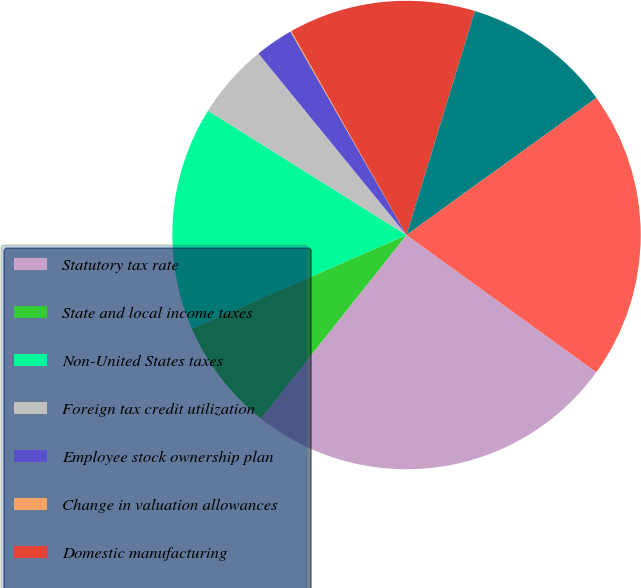Convert chart to OTSL. <chart><loc_0><loc_0><loc_500><loc_500><pie_chart><fcel>Statutory tax rate<fcel>State and local income taxes<fcel>Non-United States taxes<fcel>Foreign tax credit utilization<fcel>Employee stock ownership plan<fcel>Change in valuation allowances<fcel>Domestic manufacturing<fcel>Adjustments for prior period<fcel>EFFECTIVE INCOME TAX RATE<nl><fcel>25.72%<fcel>7.77%<fcel>15.46%<fcel>5.2%<fcel>2.64%<fcel>0.07%<fcel>12.9%<fcel>10.33%<fcel>19.91%<nl></chart> 